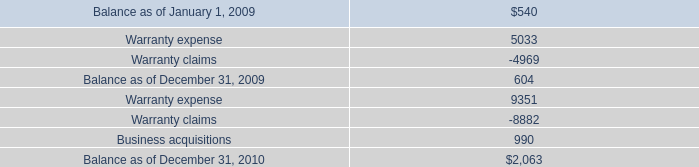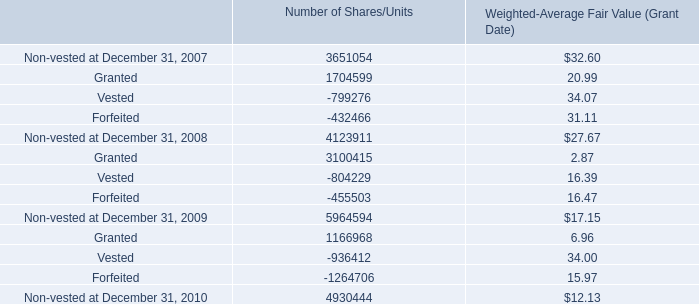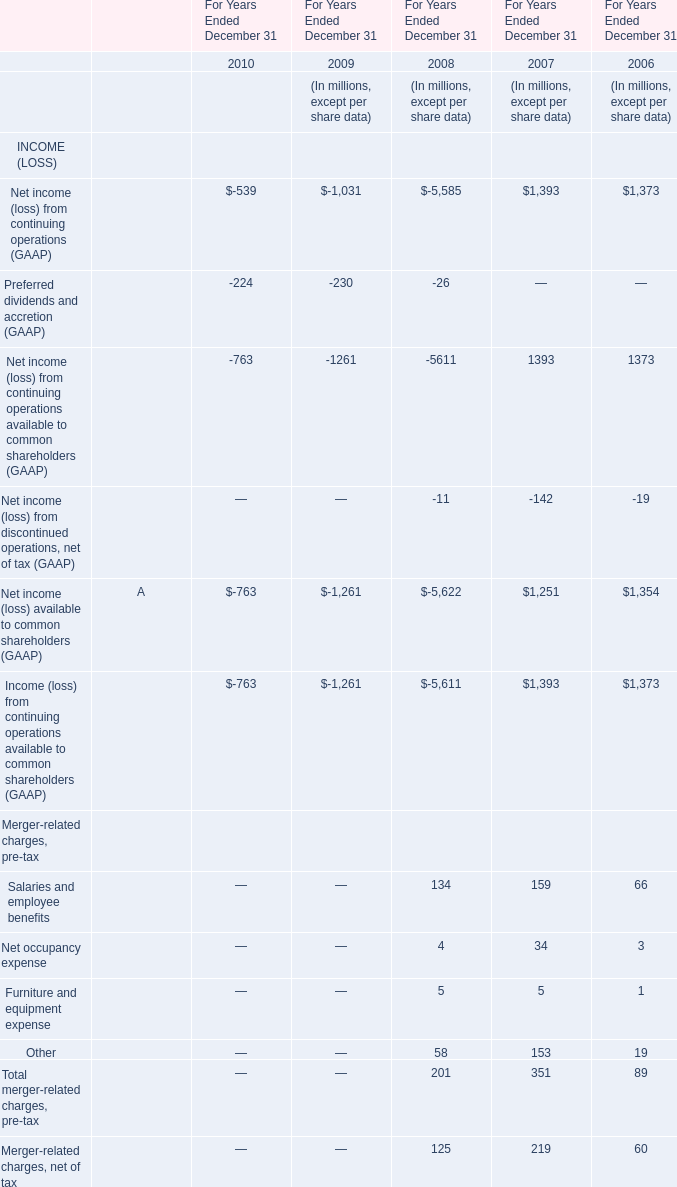what was the percentage change in warranty reserve between 2009 and 2010? 
Computations: ((2063 - 604) / 604)
Answer: 2.41556. 